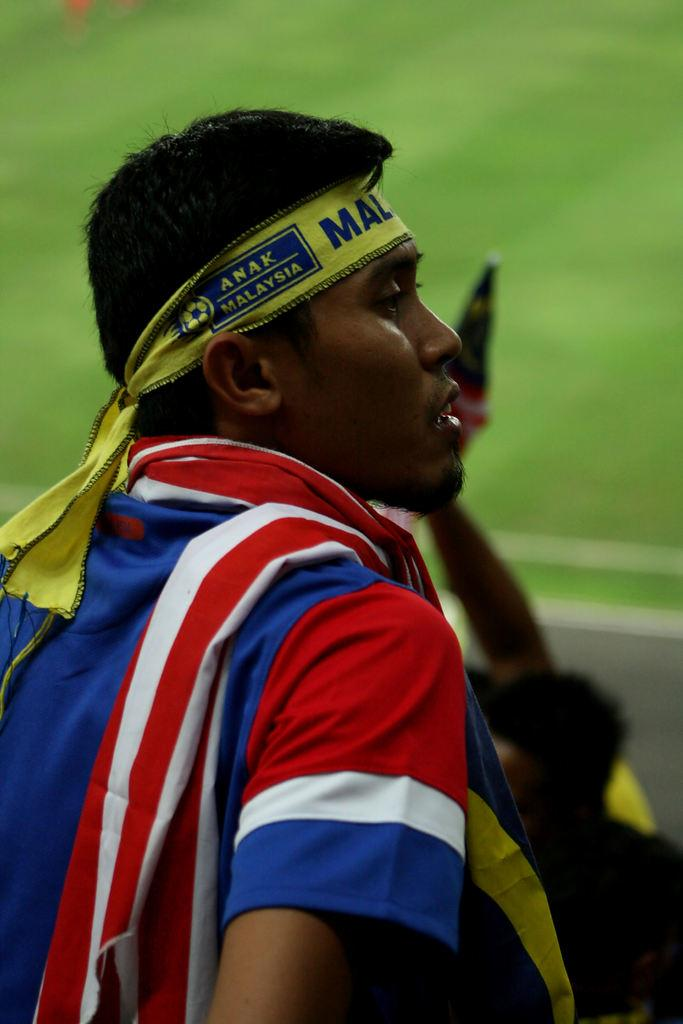<image>
Provide a brief description of the given image. A fan in the crowd wears a yellow bandanna on his head that says ANAK MALAYSIA 